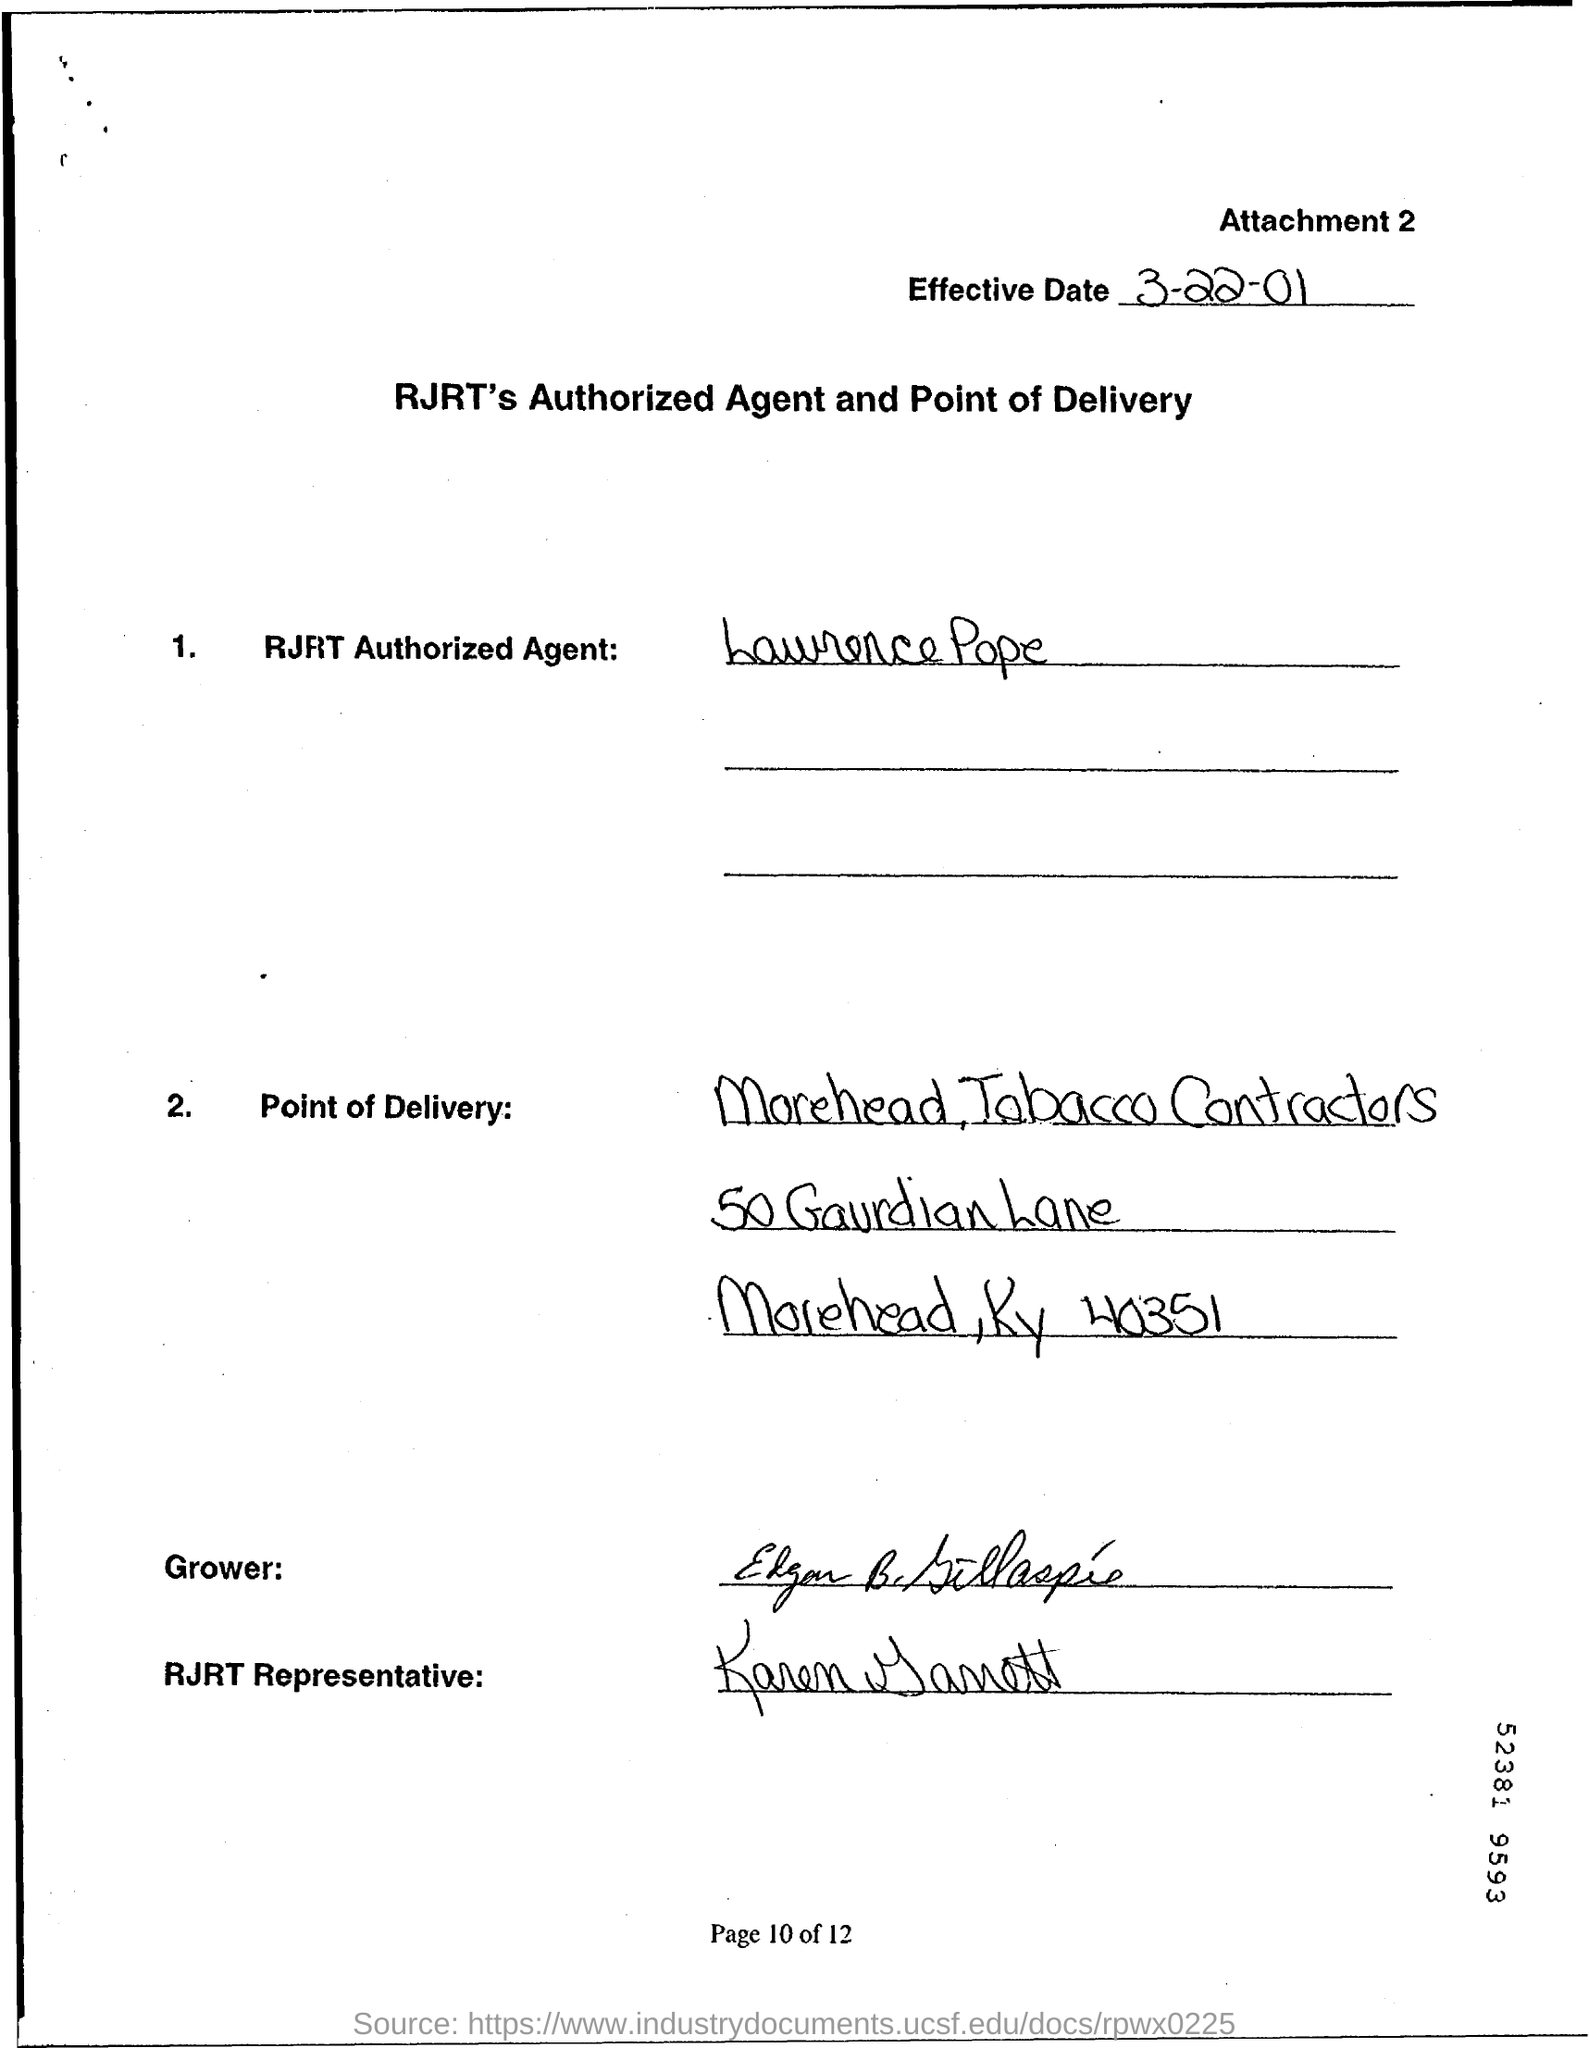When is the Effective Date?
Your answer should be very brief. 3-22-01. Who is the RJRT Authorized Agent?
Provide a short and direct response. Lawrence Pope. 